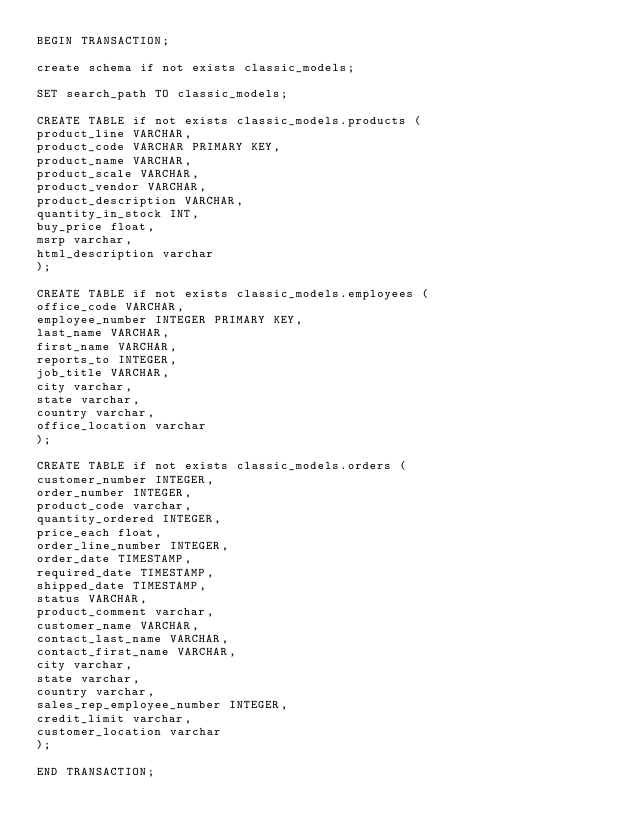Convert code to text. <code><loc_0><loc_0><loc_500><loc_500><_SQL_>BEGIN TRANSACTION;

create schema if not exists classic_models;

SET search_path TO classic_models;

CREATE TABLE if not exists classic_models.products (
product_line VARCHAR,
product_code VARCHAR PRIMARY KEY,
product_name VARCHAR,
product_scale VARCHAR,
product_vendor VARCHAR,
product_description VARCHAR,
quantity_in_stock INT,
buy_price float,
msrp varchar,
html_description varchar
);

CREATE TABLE if not exists classic_models.employees (
office_code VARCHAR,
employee_number INTEGER PRIMARY KEY,
last_name VARCHAR,
first_name VARCHAR,
reports_to INTEGER,
job_title VARCHAR,
city varchar,
state varchar, 
country varchar,
office_location varchar
);

CREATE TABLE if not exists classic_models.orders (
customer_number INTEGER,
order_number INTEGER,
product_code varchar,
quantity_ordered INTEGER,
price_each float,
order_line_number INTEGER,
order_date TIMESTAMP,
required_date TIMESTAMP,
shipped_date TIMESTAMP,
status VARCHAR,
product_comment varchar,
customer_name VARCHAR,
contact_last_name VARCHAR,
contact_first_name VARCHAR,
city varchar,
state varchar, 
country varchar,
sales_rep_employee_number INTEGER,
credit_limit varchar,
customer_location varchar
);

END TRANSACTION;</code> 